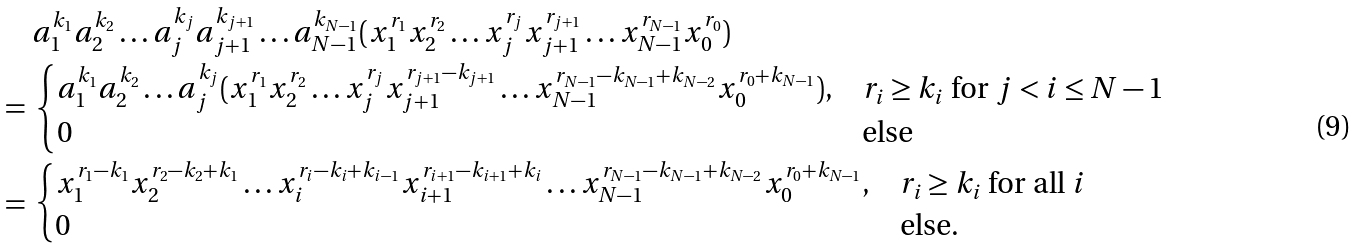Convert formula to latex. <formula><loc_0><loc_0><loc_500><loc_500>& a _ { 1 } ^ { k _ { 1 } } a _ { 2 } ^ { k _ { 2 } } \dots a _ { j } ^ { k _ { j } } a _ { j + 1 } ^ { k _ { j + 1 } } \dots a _ { N - 1 } ^ { k _ { N - 1 } } ( x _ { 1 } ^ { r _ { 1 } } x _ { 2 } ^ { r _ { 2 } } \dots x _ { j } ^ { r _ { j } } x _ { j + 1 } ^ { r _ { j + 1 } } \dots x _ { N - 1 } ^ { r _ { N - 1 } } x _ { 0 } ^ { r _ { 0 } } ) \\ = \ & \begin{cases} a _ { 1 } ^ { k _ { 1 } } a _ { 2 } ^ { k _ { 2 } } \dots a _ { j } ^ { k _ { j } } ( x _ { 1 } ^ { r _ { 1 } } x _ { 2 } ^ { r _ { 2 } } \dots x _ { j } ^ { r _ { j } } x _ { j + 1 } ^ { r _ { j + 1 } - k _ { j + 1 } } \dots x _ { N - 1 } ^ { r _ { N - 1 } - k _ { N - 1 } + k _ { N - 2 } } x _ { 0 } ^ { r _ { 0 } + k _ { N - 1 } } ) , & r _ { i } \geq k _ { i } \text { for } j < i \leq { N - 1 } \\ 0 & \text {else} \end{cases} \\ = \ & \begin{cases} x _ { 1 } ^ { r _ { 1 } - k _ { 1 } } x _ { 2 } ^ { r _ { 2 } - k _ { 2 } + k _ { 1 } } \dots x _ { i } ^ { r _ { i } - k _ { i } + k _ { i - 1 } } x _ { i + 1 } ^ { r _ { i + 1 } - k _ { i + 1 } + k _ { i } } \dots x _ { N - 1 } ^ { r _ { N - 1 } - k _ { N - 1 } + k _ { N - 2 } } x _ { 0 } ^ { r _ { 0 } + k _ { N - 1 } } , & r _ { i } \geq k _ { i } \text { for all } i \\ 0 & \text {else.} \end{cases}</formula> 